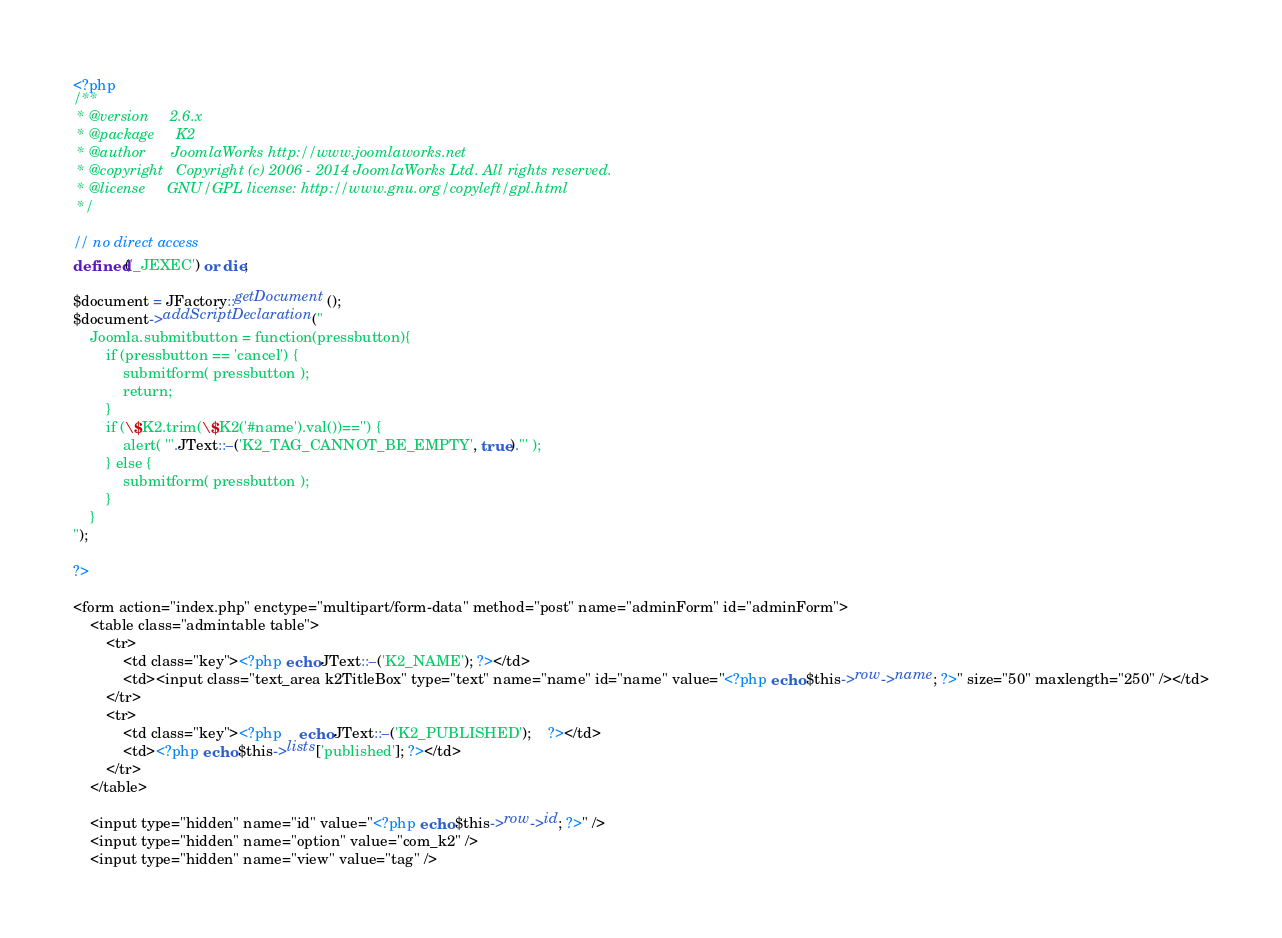<code> <loc_0><loc_0><loc_500><loc_500><_PHP_><?php
/**
 * @version		2.6.x
 * @package		K2
 * @author		JoomlaWorks http://www.joomlaworks.net
 * @copyright	Copyright (c) 2006 - 2014 JoomlaWorks Ltd. All rights reserved.
 * @license		GNU/GPL license: http://www.gnu.org/copyleft/gpl.html
 */

// no direct access
defined('_JEXEC') or die;

$document = JFactory::getDocument();
$document->addScriptDeclaration("
	Joomla.submitbutton = function(pressbutton){
		if (pressbutton == 'cancel') {
			submitform( pressbutton );
			return;
		}
		if (\$K2.trim(\$K2('#name').val())=='') {
			alert( '".JText::_('K2_TAG_CANNOT_BE_EMPTY', true)."' );
		} else {
			submitform( pressbutton );
		}
	}
");

?>

<form action="index.php" enctype="multipart/form-data" method="post" name="adminForm" id="adminForm">
	<table class="admintable table">
		<tr>
			<td class="key"><?php echo JText::_('K2_NAME'); ?></td>
			<td><input class="text_area k2TitleBox" type="text" name="name" id="name" value="<?php echo $this->row->name; ?>" size="50" maxlength="250" /></td>
		</tr>
		<tr>
			<td class="key"><?php	echo JText::_('K2_PUBLISHED');	?></td>
			<td><?php echo $this->lists['published']; ?></td>
		</tr>
	</table>

	<input type="hidden" name="id" value="<?php echo $this->row->id; ?>" />
	<input type="hidden" name="option" value="com_k2" />
	<input type="hidden" name="view" value="tag" /></code> 